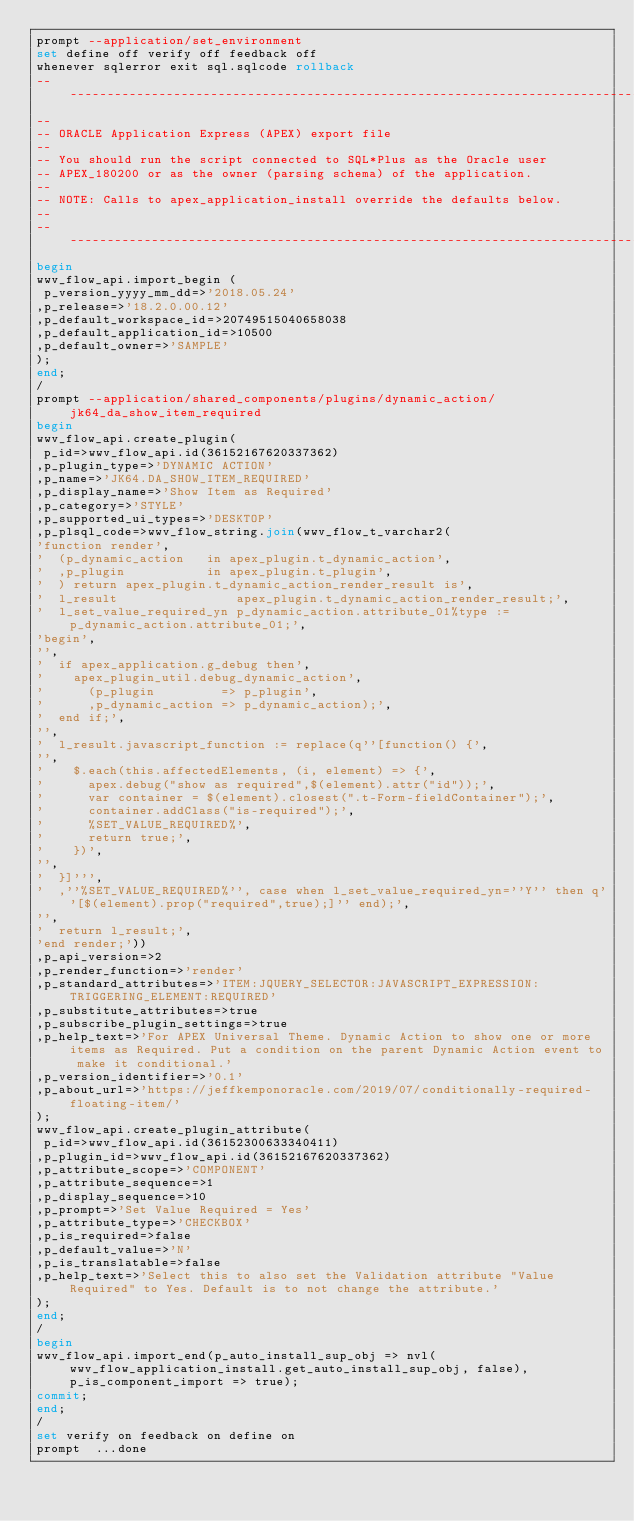Convert code to text. <code><loc_0><loc_0><loc_500><loc_500><_SQL_>prompt --application/set_environment
set define off verify off feedback off
whenever sqlerror exit sql.sqlcode rollback
--------------------------------------------------------------------------------
--
-- ORACLE Application Express (APEX) export file
--
-- You should run the script connected to SQL*Plus as the Oracle user
-- APEX_180200 or as the owner (parsing schema) of the application.
--
-- NOTE: Calls to apex_application_install override the defaults below.
--
--------------------------------------------------------------------------------
begin
wwv_flow_api.import_begin (
 p_version_yyyy_mm_dd=>'2018.05.24'
,p_release=>'18.2.0.00.12'
,p_default_workspace_id=>20749515040658038
,p_default_application_id=>10500
,p_default_owner=>'SAMPLE'
);
end;
/
prompt --application/shared_components/plugins/dynamic_action/jk64_da_show_item_required
begin
wwv_flow_api.create_plugin(
 p_id=>wwv_flow_api.id(36152167620337362)
,p_plugin_type=>'DYNAMIC ACTION'
,p_name=>'JK64.DA_SHOW_ITEM_REQUIRED'
,p_display_name=>'Show Item as Required'
,p_category=>'STYLE'
,p_supported_ui_types=>'DESKTOP'
,p_plsql_code=>wwv_flow_string.join(wwv_flow_t_varchar2(
'function render',
'  (p_dynamic_action   in apex_plugin.t_dynamic_action',
'  ,p_plugin           in apex_plugin.t_plugin',
'  ) return apex_plugin.t_dynamic_action_render_result is',
'  l_result                apex_plugin.t_dynamic_action_render_result;',
'  l_set_value_required_yn p_dynamic_action.attribute_01%type := p_dynamic_action.attribute_01;',
'begin',
'',
'  if apex_application.g_debug then',
'    apex_plugin_util.debug_dynamic_action',
'      (p_plugin         => p_plugin',
'      ,p_dynamic_action => p_dynamic_action);',
'  end if;',
'',
'  l_result.javascript_function := replace(q''[function() {',
'',
'    $.each(this.affectedElements, (i, element) => {',
'      apex.debug("show as required",$(element).attr("id"));',
'      var container = $(element).closest(".t-Form-fieldContainer");',
'      container.addClass("is-required");',
'      %SET_VALUE_REQUIRED%',
'      return true;',
'    })',
'',
'  }]''',
'  ,''%SET_VALUE_REQUIRED%'', case when l_set_value_required_yn=''Y'' then q''[$(element).prop("required",true);]'' end);',
'',
'  return l_result;',
'end render;'))
,p_api_version=>2
,p_render_function=>'render'
,p_standard_attributes=>'ITEM:JQUERY_SELECTOR:JAVASCRIPT_EXPRESSION:TRIGGERING_ELEMENT:REQUIRED'
,p_substitute_attributes=>true
,p_subscribe_plugin_settings=>true
,p_help_text=>'For APEX Universal Theme. Dynamic Action to show one or more items as Required. Put a condition on the parent Dynamic Action event to make it conditional.'
,p_version_identifier=>'0.1'
,p_about_url=>'https://jeffkemponoracle.com/2019/07/conditionally-required-floating-item/'
);
wwv_flow_api.create_plugin_attribute(
 p_id=>wwv_flow_api.id(36152300633340411)
,p_plugin_id=>wwv_flow_api.id(36152167620337362)
,p_attribute_scope=>'COMPONENT'
,p_attribute_sequence=>1
,p_display_sequence=>10
,p_prompt=>'Set Value Required = Yes'
,p_attribute_type=>'CHECKBOX'
,p_is_required=>false
,p_default_value=>'N'
,p_is_translatable=>false
,p_help_text=>'Select this to also set the Validation attribute "Value Required" to Yes. Default is to not change the attribute.'
);
end;
/
begin
wwv_flow_api.import_end(p_auto_install_sup_obj => nvl(wwv_flow_application_install.get_auto_install_sup_obj, false), p_is_component_import => true);
commit;
end;
/
set verify on feedback on define on
prompt  ...done
</code> 